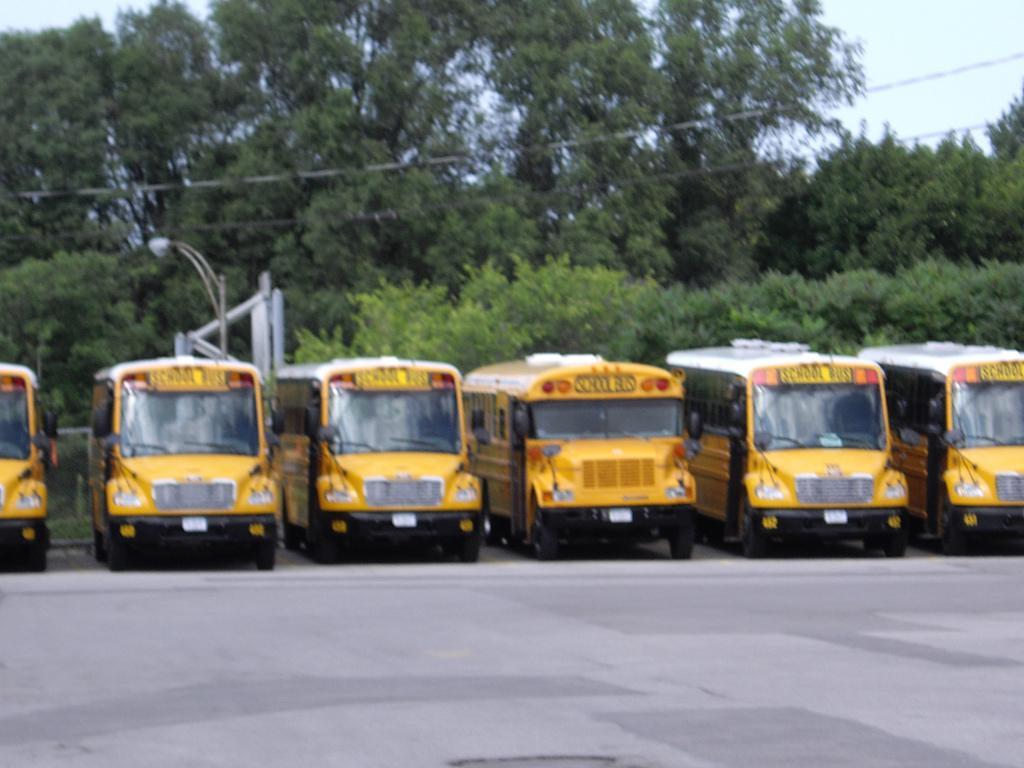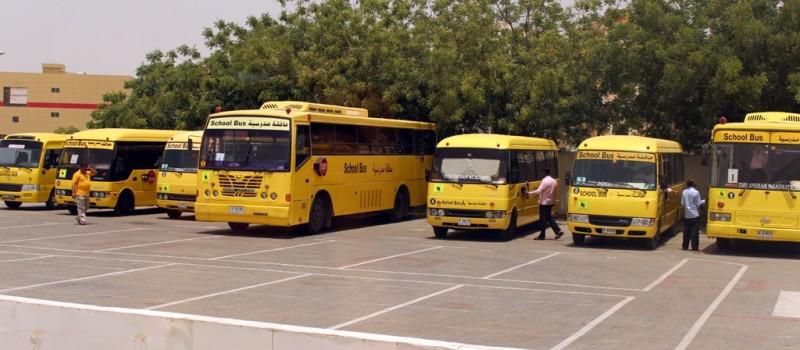The first image is the image on the left, the second image is the image on the right. For the images displayed, is the sentence "In at least one image there is a short bus facing both right and forward." factually correct? Answer yes or no. No. The first image is the image on the left, the second image is the image on the right. Assess this claim about the two images: "A bus has its passenger door open.". Correct or not? Answer yes or no. No. 